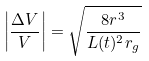Convert formula to latex. <formula><loc_0><loc_0><loc_500><loc_500>\left | \frac { \Delta V } { V } \right | = \sqrt { \frac { 8 r ^ { 3 } } { L ( t ) ^ { 2 } r _ { g } } }</formula> 